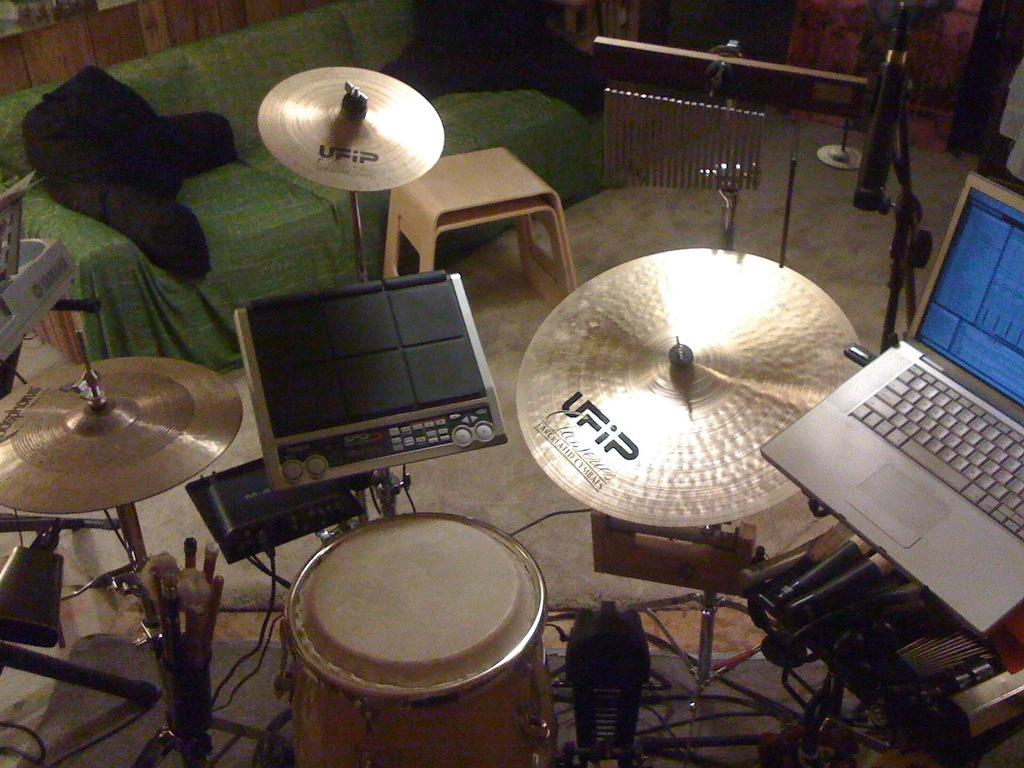What objects in the image are related to music? There are musical instruments in the image. What electronic device can be seen on the right side of the image? There is a laptop on the right side of the image. Where is the sofa located in the image? The sofa is in the left corner of the image. What device is used for amplifying sound in the image? There is a microphone at the top right of the image. What type of pickle is being used as a musical instrument in the image? There is no pickle present in the image, let alone being used as a musical instrument. 